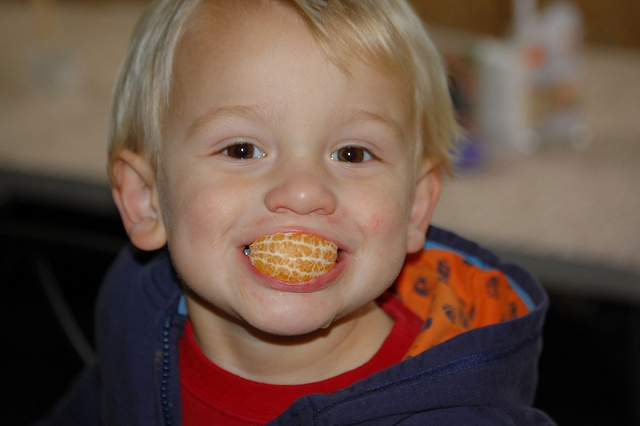Describe the objects in this image and their specific colors. I can see people in maroon, gray, black, and tan tones and orange in maroon, red, brown, and tan tones in this image. 